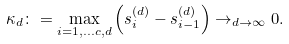<formula> <loc_0><loc_0><loc_500><loc_500>\kappa _ { d } \colon = \max _ { i = 1 , \dots c , d } \left ( s _ { i } ^ { ( d ) } - s _ { i - 1 } ^ { ( d ) } \right ) \to _ { d \to \infty } 0 .</formula> 